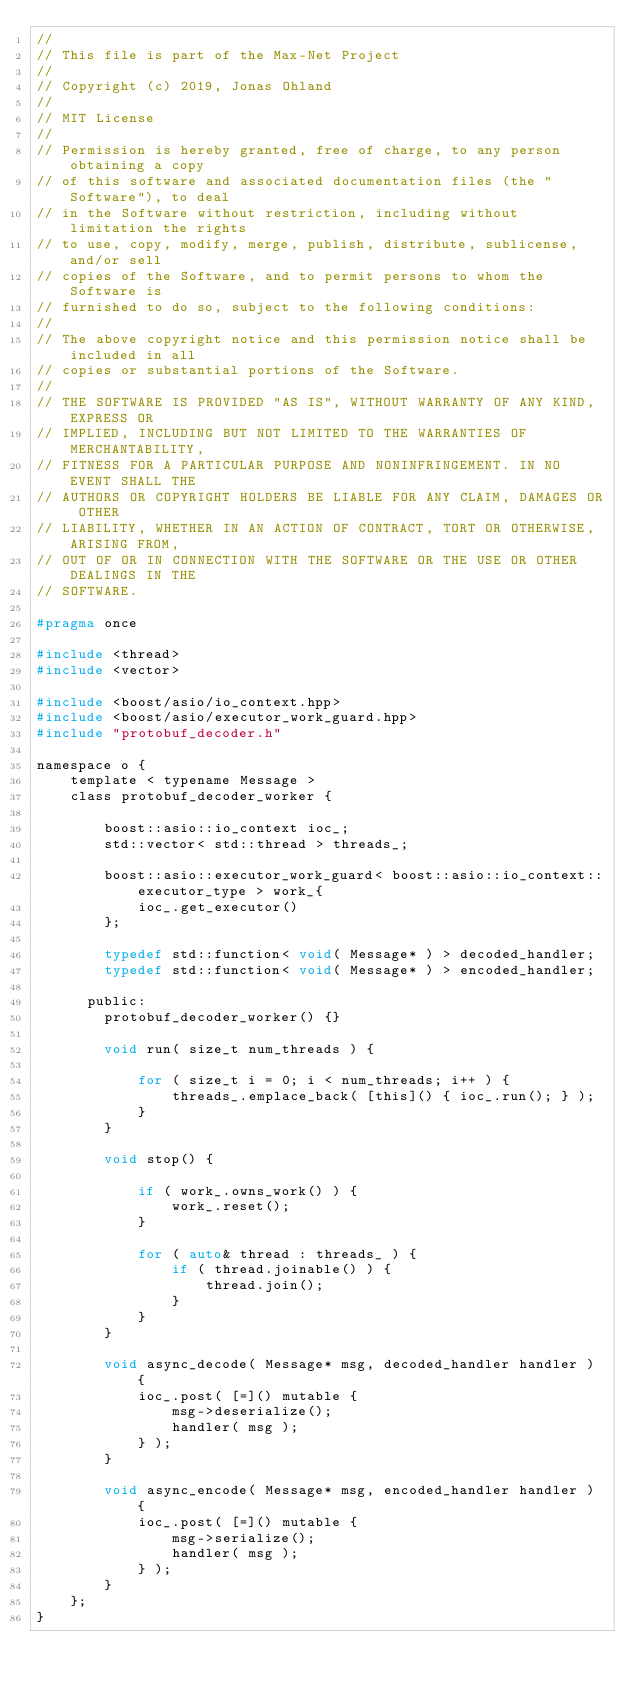<code> <loc_0><loc_0><loc_500><loc_500><_C_>//
// This file is part of the Max-Net Project
//
// Copyright (c) 2019, Jonas Ohland
//
// MIT License
//
// Permission is hereby granted, free of charge, to any person obtaining a copy
// of this software and associated documentation files (the "Software"), to deal
// in the Software without restriction, including without limitation the rights
// to use, copy, modify, merge, publish, distribute, sublicense, and/or sell
// copies of the Software, and to permit persons to whom the Software is
// furnished to do so, subject to the following conditions:
//
// The above copyright notice and this permission notice shall be included in all
// copies or substantial portions of the Software.
//
// THE SOFTWARE IS PROVIDED "AS IS", WITHOUT WARRANTY OF ANY KIND, EXPRESS OR
// IMPLIED, INCLUDING BUT NOT LIMITED TO THE WARRANTIES OF MERCHANTABILITY,
// FITNESS FOR A PARTICULAR PURPOSE AND NONINFRINGEMENT. IN NO EVENT SHALL THE
// AUTHORS OR COPYRIGHT HOLDERS BE LIABLE FOR ANY CLAIM, DAMAGES OR OTHER
// LIABILITY, WHETHER IN AN ACTION OF CONTRACT, TORT OR OTHERWISE, ARISING FROM,
// OUT OF OR IN CONNECTION WITH THE SOFTWARE OR THE USE OR OTHER DEALINGS IN THE
// SOFTWARE.

#pragma once

#include <thread>
#include <vector>

#include <boost/asio/io_context.hpp>
#include <boost/asio/executor_work_guard.hpp>
#include "protobuf_decoder.h"

namespace o {
    template < typename Message >
    class protobuf_decoder_worker {

        boost::asio::io_context ioc_;
        std::vector< std::thread > threads_;

        boost::asio::executor_work_guard< boost::asio::io_context::executor_type > work_{
            ioc_.get_executor()
        };

        typedef std::function< void( Message* ) > decoded_handler;
        typedef std::function< void( Message* ) > encoded_handler;

      public:
        protobuf_decoder_worker() {}

        void run( size_t num_threads ) {

            for ( size_t i = 0; i < num_threads; i++ ) {
                threads_.emplace_back( [this]() { ioc_.run(); } );
            }
        }

        void stop() {

            if ( work_.owns_work() ) {
                work_.reset();
            }

            for ( auto& thread : threads_ ) {
                if ( thread.joinable() ) {
                    thread.join();
                }
            }
        }

        void async_decode( Message* msg, decoded_handler handler ) {
            ioc_.post( [=]() mutable {
                msg->deserialize();
                handler( msg );
            } );
        }

        void async_encode( Message* msg, encoded_handler handler ) {
            ioc_.post( [=]() mutable {
                msg->serialize();
                handler( msg );
            } );
        }
    };
}
</code> 